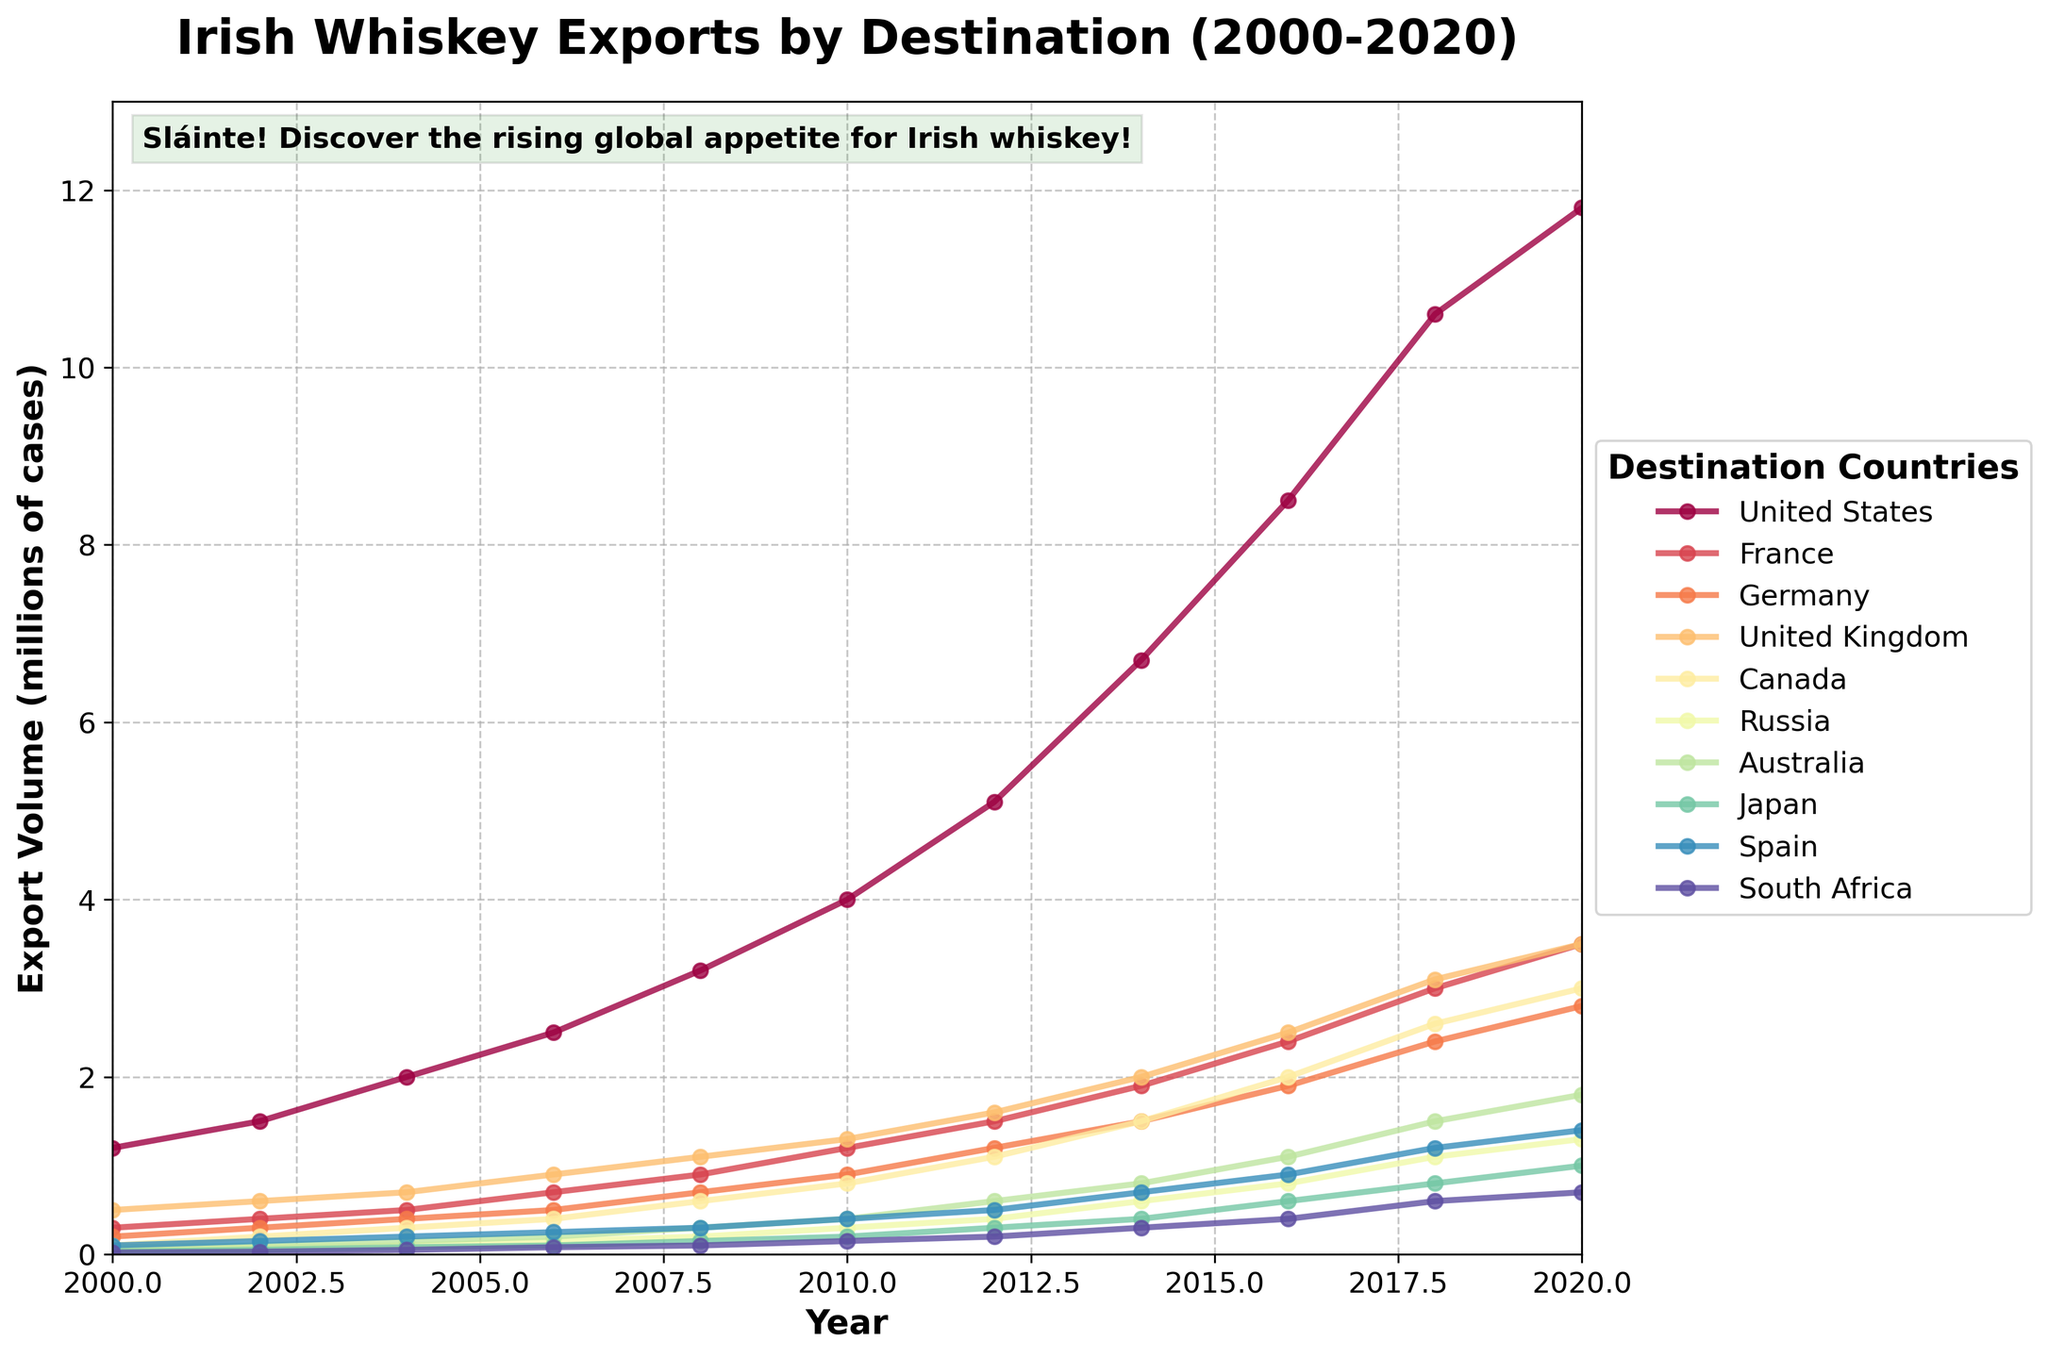Which country had the highest volume of Irish whiskey exports in 2020? By looking at the figure for the year 2020 and observing the lines, we see that the United States line is the highest.
Answer: United States Compare the export volumes to the United Kingdom and Spain in 2006. Which country imported more whiskey? In the year 2006, by looking at the lines for the United Kingdom and Spain, the United Kingdom's line is higher than Spain's.
Answer: United Kingdom What’s the total export volume of Irish whiskey to Russia from 2000 to 2020? To find the total, sum of the volumes from 2000 to 2020 (0.05 + 0.08 + 0.1 + 0.15 + 0.2 + 0.3 + 0.4 + 0.6 + 0.8 +1.1 + 1.3) = 5.08 million cases.
Answer: 5.08 Which country has seen the least growth in export volume from 2000 to 2020? By analyzing the increase in all lines from 2000 to 2020, South Africa shows the smallest growth.
Answer: South Africa What is the average yearly export volume to Canada across the two decades? Add all yearly values for Canada from 2000 to 2020 (0.1+0.2+0.3+0.4+0.6+0.8+1.1+1.5+2.0+2.6+3.0) = 12.6. Then divide by the number of years (12.6/11) = 1.15 million cases.
Answer: 1.15 Identify the year when Australia first surpassed a volume of 1 million cases. By tracing the line for Australia, it crossed 1 million in the year 2016.
Answer: 2016 How did the export volume to Japan change between 2012 and 2014? Check the values for Japan in 2012 (0.3) and 2014 (0.4). The change is 0.4 - 0.3 = 0.1 million cases.
Answer: Increased by 0.1 What’s the difference in export volume between France and Germany in 2018? In 2018, France has 3.0 million cases and Germany has 2.4 million cases. The difference is 3.0 - 2.4 = 0.6 million cases.
Answer: 0.6 What can you say about the overall trend of Irish whiskey exports to the United States over these years? The line for the United States consistently rises from 2000 to 2020, showing a substantial and continuous increase.
Answer: Continuous increase In which year did Spain see a significant rise in Irish whiskey imports compared to the previous years? Observe sharp increases in the Spain line. The noticeable jump happens between 2002 (0.15) and 2004 (0.2).
Answer: 2004 